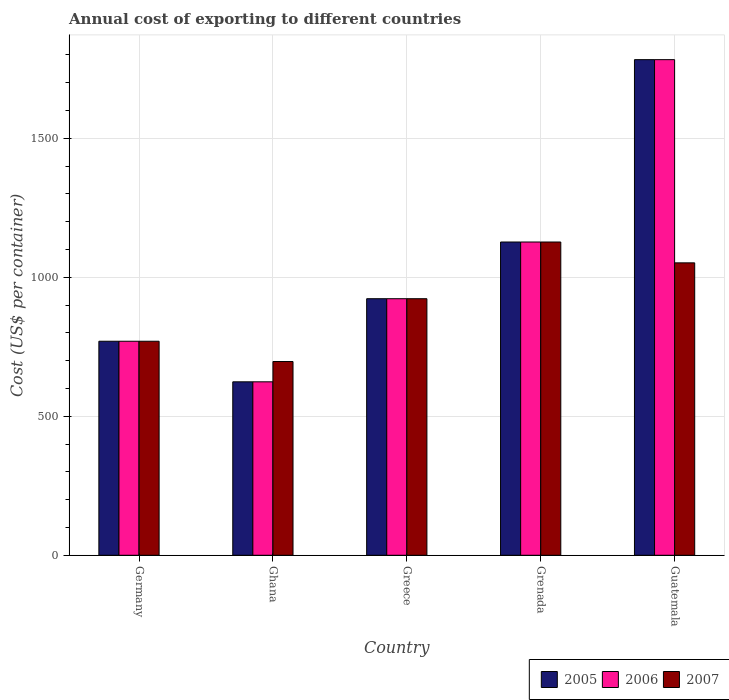How many groups of bars are there?
Offer a very short reply. 5. Are the number of bars per tick equal to the number of legend labels?
Ensure brevity in your answer.  Yes. Are the number of bars on each tick of the X-axis equal?
Your answer should be compact. Yes. How many bars are there on the 5th tick from the left?
Offer a terse response. 3. How many bars are there on the 4th tick from the right?
Your answer should be compact. 3. What is the label of the 4th group of bars from the left?
Your answer should be very brief. Grenada. In how many cases, is the number of bars for a given country not equal to the number of legend labels?
Give a very brief answer. 0. What is the total annual cost of exporting in 2007 in Greece?
Your answer should be compact. 923. Across all countries, what is the maximum total annual cost of exporting in 2006?
Your answer should be compact. 1783. Across all countries, what is the minimum total annual cost of exporting in 2006?
Offer a very short reply. 624. In which country was the total annual cost of exporting in 2005 maximum?
Your response must be concise. Guatemala. In which country was the total annual cost of exporting in 2007 minimum?
Offer a terse response. Ghana. What is the total total annual cost of exporting in 2006 in the graph?
Offer a terse response. 5227. What is the difference between the total annual cost of exporting in 2006 in Ghana and that in Greece?
Provide a succinct answer. -299. What is the average total annual cost of exporting in 2006 per country?
Provide a succinct answer. 1045.4. What is the ratio of the total annual cost of exporting in 2005 in Greece to that in Guatemala?
Ensure brevity in your answer.  0.52. Is the difference between the total annual cost of exporting in 2005 in Ghana and Guatemala greater than the difference between the total annual cost of exporting in 2006 in Ghana and Guatemala?
Keep it short and to the point. No. What is the difference between the highest and the second highest total annual cost of exporting in 2006?
Your response must be concise. -204. What is the difference between the highest and the lowest total annual cost of exporting in 2007?
Give a very brief answer. 430. In how many countries, is the total annual cost of exporting in 2006 greater than the average total annual cost of exporting in 2006 taken over all countries?
Provide a short and direct response. 2. Is it the case that in every country, the sum of the total annual cost of exporting in 2006 and total annual cost of exporting in 2007 is greater than the total annual cost of exporting in 2005?
Your answer should be very brief. Yes. Are all the bars in the graph horizontal?
Provide a succinct answer. No. How many countries are there in the graph?
Your answer should be compact. 5. What is the difference between two consecutive major ticks on the Y-axis?
Provide a succinct answer. 500. Does the graph contain any zero values?
Your answer should be compact. No. How are the legend labels stacked?
Offer a terse response. Horizontal. What is the title of the graph?
Provide a short and direct response. Annual cost of exporting to different countries. Does "1990" appear as one of the legend labels in the graph?
Keep it short and to the point. No. What is the label or title of the Y-axis?
Provide a succinct answer. Cost (US$ per container). What is the Cost (US$ per container) of 2005 in Germany?
Your answer should be very brief. 770. What is the Cost (US$ per container) in 2006 in Germany?
Make the answer very short. 770. What is the Cost (US$ per container) in 2007 in Germany?
Your answer should be very brief. 770. What is the Cost (US$ per container) in 2005 in Ghana?
Provide a short and direct response. 624. What is the Cost (US$ per container) in 2006 in Ghana?
Provide a short and direct response. 624. What is the Cost (US$ per container) of 2007 in Ghana?
Offer a very short reply. 697. What is the Cost (US$ per container) of 2005 in Greece?
Provide a succinct answer. 923. What is the Cost (US$ per container) of 2006 in Greece?
Your response must be concise. 923. What is the Cost (US$ per container) of 2007 in Greece?
Provide a succinct answer. 923. What is the Cost (US$ per container) of 2005 in Grenada?
Your response must be concise. 1127. What is the Cost (US$ per container) of 2006 in Grenada?
Ensure brevity in your answer.  1127. What is the Cost (US$ per container) in 2007 in Grenada?
Your answer should be very brief. 1127. What is the Cost (US$ per container) of 2005 in Guatemala?
Offer a terse response. 1783. What is the Cost (US$ per container) of 2006 in Guatemala?
Give a very brief answer. 1783. What is the Cost (US$ per container) in 2007 in Guatemala?
Offer a terse response. 1052. Across all countries, what is the maximum Cost (US$ per container) in 2005?
Your answer should be very brief. 1783. Across all countries, what is the maximum Cost (US$ per container) in 2006?
Your answer should be compact. 1783. Across all countries, what is the maximum Cost (US$ per container) of 2007?
Offer a terse response. 1127. Across all countries, what is the minimum Cost (US$ per container) in 2005?
Your answer should be compact. 624. Across all countries, what is the minimum Cost (US$ per container) in 2006?
Offer a very short reply. 624. Across all countries, what is the minimum Cost (US$ per container) of 2007?
Make the answer very short. 697. What is the total Cost (US$ per container) in 2005 in the graph?
Provide a short and direct response. 5227. What is the total Cost (US$ per container) of 2006 in the graph?
Provide a succinct answer. 5227. What is the total Cost (US$ per container) of 2007 in the graph?
Offer a terse response. 4569. What is the difference between the Cost (US$ per container) of 2005 in Germany and that in Ghana?
Offer a very short reply. 146. What is the difference between the Cost (US$ per container) in 2006 in Germany and that in Ghana?
Your response must be concise. 146. What is the difference between the Cost (US$ per container) of 2007 in Germany and that in Ghana?
Provide a succinct answer. 73. What is the difference between the Cost (US$ per container) in 2005 in Germany and that in Greece?
Provide a succinct answer. -153. What is the difference between the Cost (US$ per container) in 2006 in Germany and that in Greece?
Your answer should be compact. -153. What is the difference between the Cost (US$ per container) in 2007 in Germany and that in Greece?
Provide a succinct answer. -153. What is the difference between the Cost (US$ per container) of 2005 in Germany and that in Grenada?
Give a very brief answer. -357. What is the difference between the Cost (US$ per container) in 2006 in Germany and that in Grenada?
Offer a very short reply. -357. What is the difference between the Cost (US$ per container) in 2007 in Germany and that in Grenada?
Provide a short and direct response. -357. What is the difference between the Cost (US$ per container) of 2005 in Germany and that in Guatemala?
Offer a terse response. -1013. What is the difference between the Cost (US$ per container) in 2006 in Germany and that in Guatemala?
Provide a succinct answer. -1013. What is the difference between the Cost (US$ per container) of 2007 in Germany and that in Guatemala?
Ensure brevity in your answer.  -282. What is the difference between the Cost (US$ per container) in 2005 in Ghana and that in Greece?
Give a very brief answer. -299. What is the difference between the Cost (US$ per container) of 2006 in Ghana and that in Greece?
Your answer should be compact. -299. What is the difference between the Cost (US$ per container) in 2007 in Ghana and that in Greece?
Offer a very short reply. -226. What is the difference between the Cost (US$ per container) of 2005 in Ghana and that in Grenada?
Offer a very short reply. -503. What is the difference between the Cost (US$ per container) of 2006 in Ghana and that in Grenada?
Offer a very short reply. -503. What is the difference between the Cost (US$ per container) of 2007 in Ghana and that in Grenada?
Your answer should be compact. -430. What is the difference between the Cost (US$ per container) in 2005 in Ghana and that in Guatemala?
Make the answer very short. -1159. What is the difference between the Cost (US$ per container) in 2006 in Ghana and that in Guatemala?
Ensure brevity in your answer.  -1159. What is the difference between the Cost (US$ per container) of 2007 in Ghana and that in Guatemala?
Your response must be concise. -355. What is the difference between the Cost (US$ per container) in 2005 in Greece and that in Grenada?
Offer a terse response. -204. What is the difference between the Cost (US$ per container) in 2006 in Greece and that in Grenada?
Your answer should be compact. -204. What is the difference between the Cost (US$ per container) in 2007 in Greece and that in Grenada?
Your response must be concise. -204. What is the difference between the Cost (US$ per container) in 2005 in Greece and that in Guatemala?
Your answer should be compact. -860. What is the difference between the Cost (US$ per container) in 2006 in Greece and that in Guatemala?
Ensure brevity in your answer.  -860. What is the difference between the Cost (US$ per container) in 2007 in Greece and that in Guatemala?
Provide a succinct answer. -129. What is the difference between the Cost (US$ per container) of 2005 in Grenada and that in Guatemala?
Your response must be concise. -656. What is the difference between the Cost (US$ per container) in 2006 in Grenada and that in Guatemala?
Offer a very short reply. -656. What is the difference between the Cost (US$ per container) of 2005 in Germany and the Cost (US$ per container) of 2006 in Ghana?
Make the answer very short. 146. What is the difference between the Cost (US$ per container) in 2006 in Germany and the Cost (US$ per container) in 2007 in Ghana?
Your response must be concise. 73. What is the difference between the Cost (US$ per container) of 2005 in Germany and the Cost (US$ per container) of 2006 in Greece?
Make the answer very short. -153. What is the difference between the Cost (US$ per container) of 2005 in Germany and the Cost (US$ per container) of 2007 in Greece?
Make the answer very short. -153. What is the difference between the Cost (US$ per container) of 2006 in Germany and the Cost (US$ per container) of 2007 in Greece?
Provide a succinct answer. -153. What is the difference between the Cost (US$ per container) of 2005 in Germany and the Cost (US$ per container) of 2006 in Grenada?
Ensure brevity in your answer.  -357. What is the difference between the Cost (US$ per container) of 2005 in Germany and the Cost (US$ per container) of 2007 in Grenada?
Make the answer very short. -357. What is the difference between the Cost (US$ per container) of 2006 in Germany and the Cost (US$ per container) of 2007 in Grenada?
Make the answer very short. -357. What is the difference between the Cost (US$ per container) of 2005 in Germany and the Cost (US$ per container) of 2006 in Guatemala?
Ensure brevity in your answer.  -1013. What is the difference between the Cost (US$ per container) in 2005 in Germany and the Cost (US$ per container) in 2007 in Guatemala?
Keep it short and to the point. -282. What is the difference between the Cost (US$ per container) in 2006 in Germany and the Cost (US$ per container) in 2007 in Guatemala?
Offer a terse response. -282. What is the difference between the Cost (US$ per container) of 2005 in Ghana and the Cost (US$ per container) of 2006 in Greece?
Offer a terse response. -299. What is the difference between the Cost (US$ per container) of 2005 in Ghana and the Cost (US$ per container) of 2007 in Greece?
Your answer should be very brief. -299. What is the difference between the Cost (US$ per container) of 2006 in Ghana and the Cost (US$ per container) of 2007 in Greece?
Offer a very short reply. -299. What is the difference between the Cost (US$ per container) of 2005 in Ghana and the Cost (US$ per container) of 2006 in Grenada?
Your answer should be very brief. -503. What is the difference between the Cost (US$ per container) in 2005 in Ghana and the Cost (US$ per container) in 2007 in Grenada?
Your answer should be very brief. -503. What is the difference between the Cost (US$ per container) of 2006 in Ghana and the Cost (US$ per container) of 2007 in Grenada?
Offer a terse response. -503. What is the difference between the Cost (US$ per container) of 2005 in Ghana and the Cost (US$ per container) of 2006 in Guatemala?
Your response must be concise. -1159. What is the difference between the Cost (US$ per container) in 2005 in Ghana and the Cost (US$ per container) in 2007 in Guatemala?
Your answer should be very brief. -428. What is the difference between the Cost (US$ per container) of 2006 in Ghana and the Cost (US$ per container) of 2007 in Guatemala?
Ensure brevity in your answer.  -428. What is the difference between the Cost (US$ per container) of 2005 in Greece and the Cost (US$ per container) of 2006 in Grenada?
Ensure brevity in your answer.  -204. What is the difference between the Cost (US$ per container) of 2005 in Greece and the Cost (US$ per container) of 2007 in Grenada?
Provide a short and direct response. -204. What is the difference between the Cost (US$ per container) in 2006 in Greece and the Cost (US$ per container) in 2007 in Grenada?
Provide a succinct answer. -204. What is the difference between the Cost (US$ per container) in 2005 in Greece and the Cost (US$ per container) in 2006 in Guatemala?
Give a very brief answer. -860. What is the difference between the Cost (US$ per container) in 2005 in Greece and the Cost (US$ per container) in 2007 in Guatemala?
Offer a terse response. -129. What is the difference between the Cost (US$ per container) of 2006 in Greece and the Cost (US$ per container) of 2007 in Guatemala?
Ensure brevity in your answer.  -129. What is the difference between the Cost (US$ per container) in 2005 in Grenada and the Cost (US$ per container) in 2006 in Guatemala?
Offer a very short reply. -656. What is the difference between the Cost (US$ per container) of 2006 in Grenada and the Cost (US$ per container) of 2007 in Guatemala?
Your answer should be compact. 75. What is the average Cost (US$ per container) in 2005 per country?
Offer a very short reply. 1045.4. What is the average Cost (US$ per container) in 2006 per country?
Your answer should be very brief. 1045.4. What is the average Cost (US$ per container) in 2007 per country?
Ensure brevity in your answer.  913.8. What is the difference between the Cost (US$ per container) in 2006 and Cost (US$ per container) in 2007 in Germany?
Offer a terse response. 0. What is the difference between the Cost (US$ per container) of 2005 and Cost (US$ per container) of 2007 in Ghana?
Offer a terse response. -73. What is the difference between the Cost (US$ per container) in 2006 and Cost (US$ per container) in 2007 in Ghana?
Your response must be concise. -73. What is the difference between the Cost (US$ per container) in 2006 and Cost (US$ per container) in 2007 in Greece?
Your response must be concise. 0. What is the difference between the Cost (US$ per container) of 2005 and Cost (US$ per container) of 2006 in Grenada?
Your answer should be compact. 0. What is the difference between the Cost (US$ per container) in 2005 and Cost (US$ per container) in 2006 in Guatemala?
Your answer should be very brief. 0. What is the difference between the Cost (US$ per container) in 2005 and Cost (US$ per container) in 2007 in Guatemala?
Make the answer very short. 731. What is the difference between the Cost (US$ per container) of 2006 and Cost (US$ per container) of 2007 in Guatemala?
Your answer should be compact. 731. What is the ratio of the Cost (US$ per container) in 2005 in Germany to that in Ghana?
Provide a short and direct response. 1.23. What is the ratio of the Cost (US$ per container) of 2006 in Germany to that in Ghana?
Your response must be concise. 1.23. What is the ratio of the Cost (US$ per container) in 2007 in Germany to that in Ghana?
Ensure brevity in your answer.  1.1. What is the ratio of the Cost (US$ per container) in 2005 in Germany to that in Greece?
Ensure brevity in your answer.  0.83. What is the ratio of the Cost (US$ per container) in 2006 in Germany to that in Greece?
Make the answer very short. 0.83. What is the ratio of the Cost (US$ per container) in 2007 in Germany to that in Greece?
Offer a very short reply. 0.83. What is the ratio of the Cost (US$ per container) of 2005 in Germany to that in Grenada?
Offer a terse response. 0.68. What is the ratio of the Cost (US$ per container) of 2006 in Germany to that in Grenada?
Ensure brevity in your answer.  0.68. What is the ratio of the Cost (US$ per container) of 2007 in Germany to that in Grenada?
Keep it short and to the point. 0.68. What is the ratio of the Cost (US$ per container) of 2005 in Germany to that in Guatemala?
Your answer should be very brief. 0.43. What is the ratio of the Cost (US$ per container) in 2006 in Germany to that in Guatemala?
Your response must be concise. 0.43. What is the ratio of the Cost (US$ per container) of 2007 in Germany to that in Guatemala?
Your response must be concise. 0.73. What is the ratio of the Cost (US$ per container) in 2005 in Ghana to that in Greece?
Provide a succinct answer. 0.68. What is the ratio of the Cost (US$ per container) in 2006 in Ghana to that in Greece?
Make the answer very short. 0.68. What is the ratio of the Cost (US$ per container) in 2007 in Ghana to that in Greece?
Provide a short and direct response. 0.76. What is the ratio of the Cost (US$ per container) in 2005 in Ghana to that in Grenada?
Ensure brevity in your answer.  0.55. What is the ratio of the Cost (US$ per container) of 2006 in Ghana to that in Grenada?
Offer a very short reply. 0.55. What is the ratio of the Cost (US$ per container) in 2007 in Ghana to that in Grenada?
Keep it short and to the point. 0.62. What is the ratio of the Cost (US$ per container) of 2007 in Ghana to that in Guatemala?
Keep it short and to the point. 0.66. What is the ratio of the Cost (US$ per container) in 2005 in Greece to that in Grenada?
Give a very brief answer. 0.82. What is the ratio of the Cost (US$ per container) in 2006 in Greece to that in Grenada?
Give a very brief answer. 0.82. What is the ratio of the Cost (US$ per container) of 2007 in Greece to that in Grenada?
Your response must be concise. 0.82. What is the ratio of the Cost (US$ per container) in 2005 in Greece to that in Guatemala?
Provide a succinct answer. 0.52. What is the ratio of the Cost (US$ per container) of 2006 in Greece to that in Guatemala?
Provide a succinct answer. 0.52. What is the ratio of the Cost (US$ per container) in 2007 in Greece to that in Guatemala?
Your answer should be very brief. 0.88. What is the ratio of the Cost (US$ per container) in 2005 in Grenada to that in Guatemala?
Give a very brief answer. 0.63. What is the ratio of the Cost (US$ per container) in 2006 in Grenada to that in Guatemala?
Provide a succinct answer. 0.63. What is the ratio of the Cost (US$ per container) in 2007 in Grenada to that in Guatemala?
Make the answer very short. 1.07. What is the difference between the highest and the second highest Cost (US$ per container) of 2005?
Make the answer very short. 656. What is the difference between the highest and the second highest Cost (US$ per container) of 2006?
Offer a terse response. 656. What is the difference between the highest and the lowest Cost (US$ per container) of 2005?
Give a very brief answer. 1159. What is the difference between the highest and the lowest Cost (US$ per container) in 2006?
Provide a short and direct response. 1159. What is the difference between the highest and the lowest Cost (US$ per container) of 2007?
Offer a terse response. 430. 